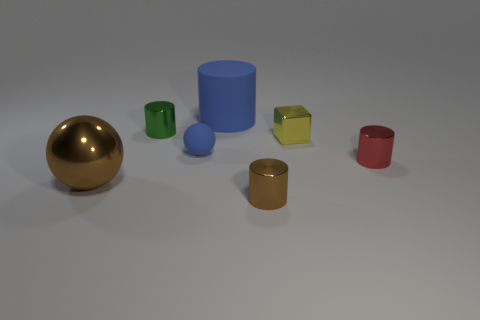Add 1 big cylinders. How many objects exist? 8 Subtract all small shiny cylinders. How many cylinders are left? 1 Subtract 2 cylinders. How many cylinders are left? 2 Subtract all blue cylinders. How many cylinders are left? 3 Add 6 small blue matte objects. How many small blue matte objects are left? 7 Add 4 blue spheres. How many blue spheres exist? 5 Subtract 0 purple blocks. How many objects are left? 7 Subtract all cylinders. How many objects are left? 3 Subtract all cyan cylinders. Subtract all cyan spheres. How many cylinders are left? 4 Subtract all blue spheres. How many blue cylinders are left? 1 